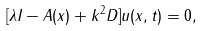<formula> <loc_0><loc_0><loc_500><loc_500>[ \lambda I - A ( x ) + k ^ { 2 } D ] u ( x , t ) = 0 ,</formula> 